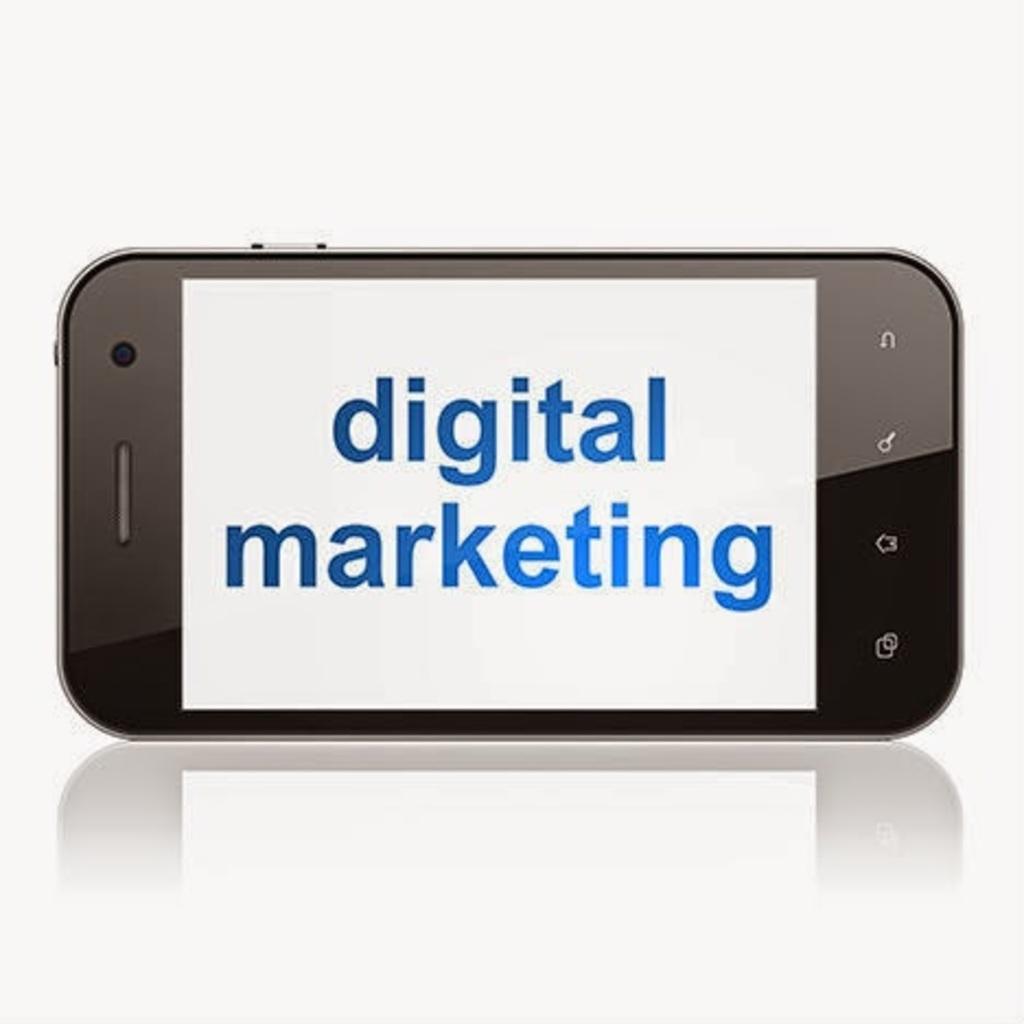In one or two sentences, can you explain what this image depicts? In this image I can see a smartphone kept horizontally on a platform. I can see the screen with some text. I can see the reflection of the phone at the bottom. 